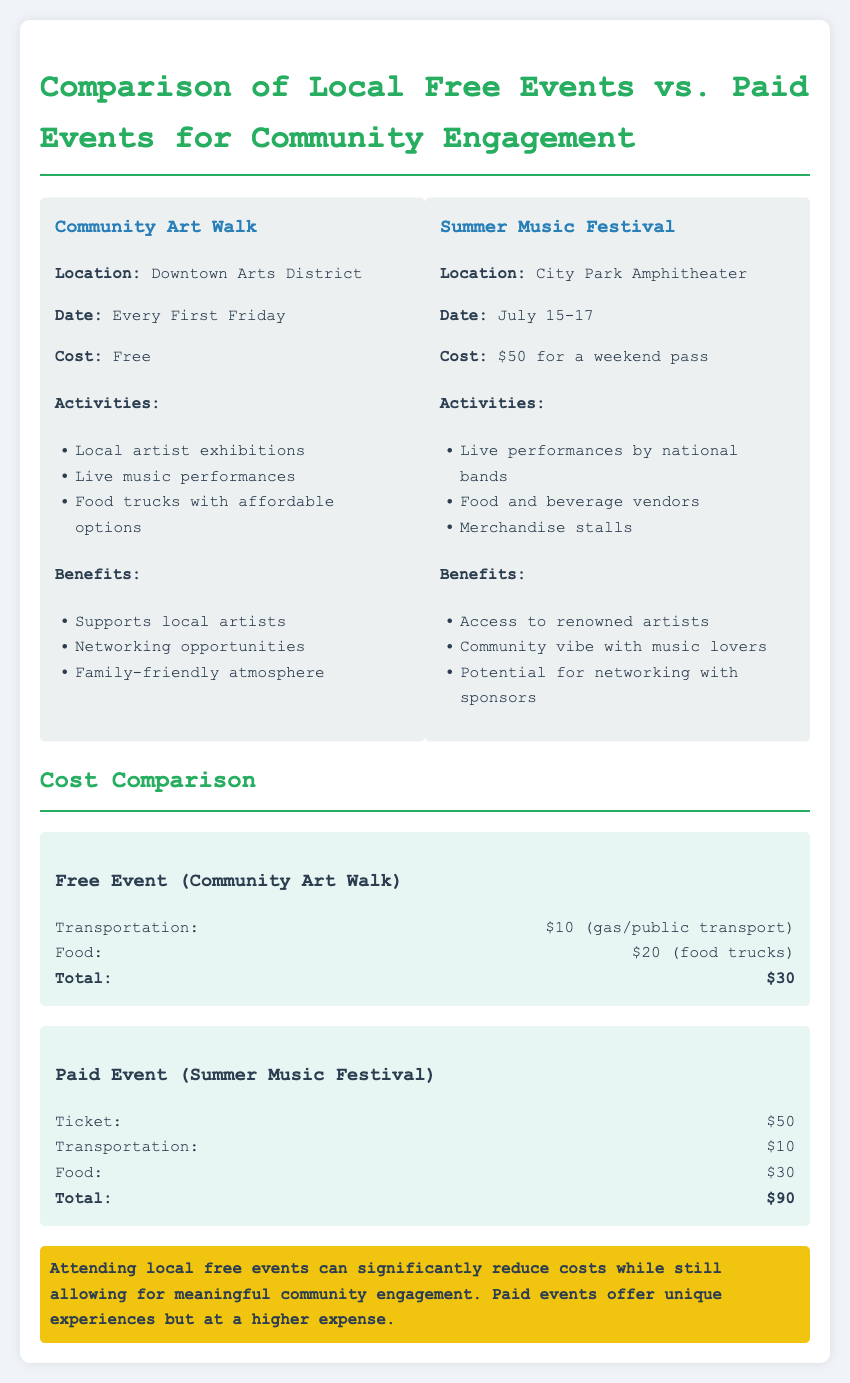What is the cost of the Community Art Walk? The document states that the cost of the Community Art Walk is free.
Answer: Free What is the location of the Summer Music Festival? The location of the Summer Music Festival is mentioned in the document as City Park Amphitheater.
Answer: City Park Amphitheater What are the dates for the Community Art Walk? The document lists the dates for the Community Art Walk as every First Friday.
Answer: Every First Friday What is the total cost of attending the Community Art Walk? The total cost of attending the Community Art Walk is calculated as $10 for transportation and $20 for food, totaling $30.
Answer: $30 What is the total cost for the Summer Music Festival including food and transportation? The total cost for the Summer Music Festival includes a $50 ticket, $10 for transportation, and $30 for food, totaling $90.
Answer: $90 What types of activities can be found at the Summer Music Festival? The Summer Music Festival features live performances by national bands, food and beverage vendors, and merchandise stalls.
Answer: Live performances by national bands, food and beverage vendors, merchandise stalls What is one benefit of attending the Community Art Walk? One benefit of the Community Art Walk is to support local artists.
Answer: Supports local artists What is the highlighted takeaway from the document? The document highlights that attending local free events can significantly reduce costs while still allowing for meaningful community engagement.
Answer: Attending local free events can significantly reduce costs while still allowing for meaningful community engagement 